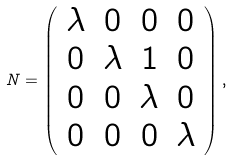<formula> <loc_0><loc_0><loc_500><loc_500>N = \left ( \begin{array} { c c c c } \lambda & 0 & 0 & 0 \\ 0 & \lambda & 1 & 0 \\ 0 & 0 & \lambda & 0 \\ 0 & 0 & 0 & \lambda \end{array} \right ) ,</formula> 